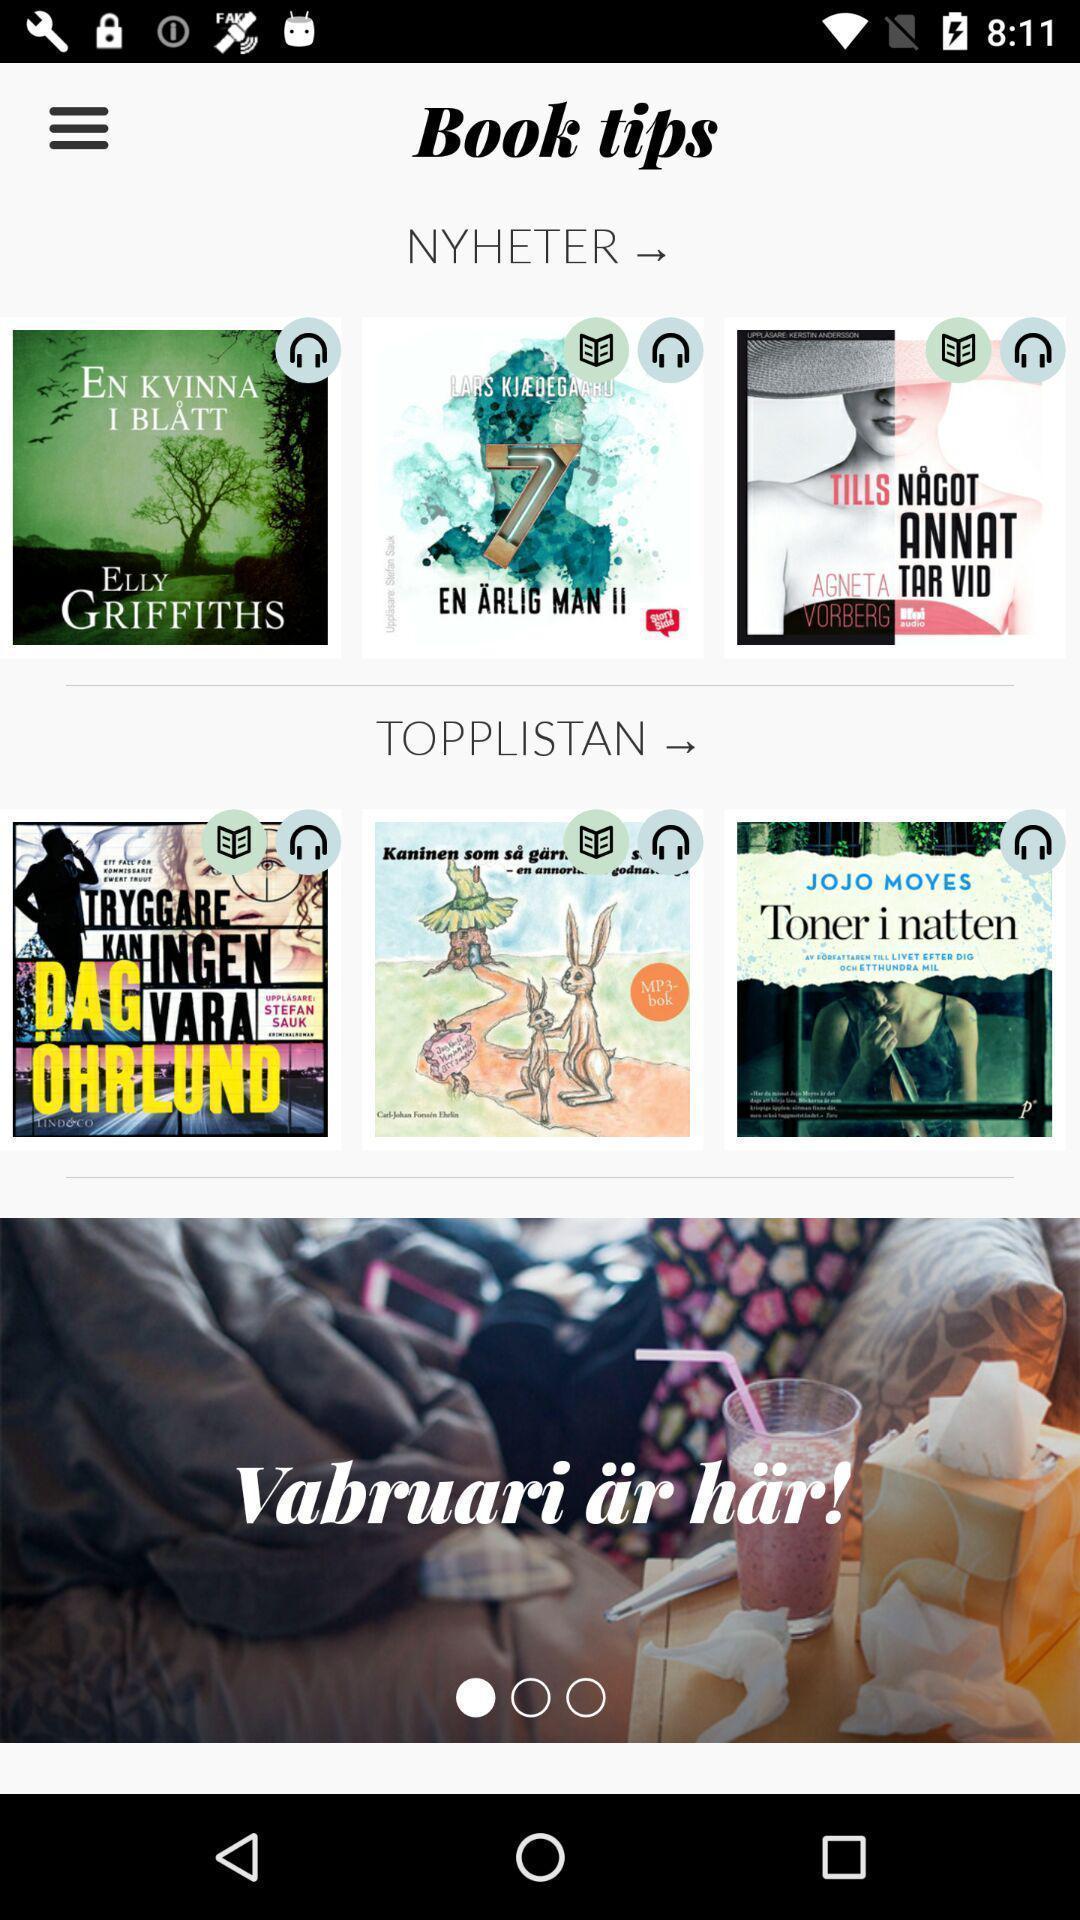Provide a description of this screenshot. Screen shows different books. 